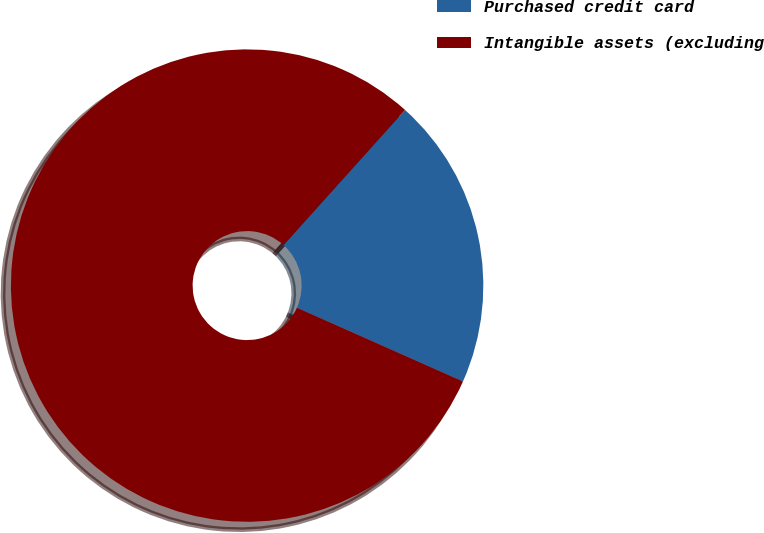<chart> <loc_0><loc_0><loc_500><loc_500><pie_chart><fcel>Purchased credit card<fcel>Intangible assets (excluding<nl><fcel>20.0%<fcel>80.0%<nl></chart> 